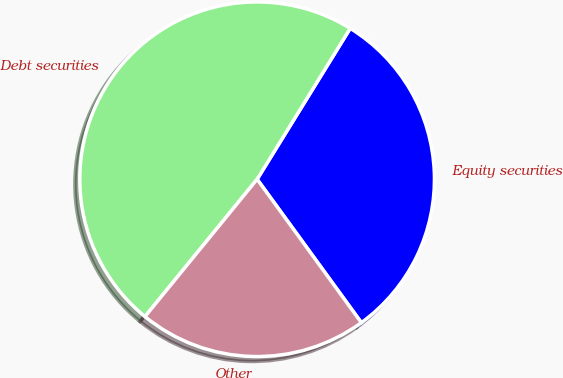Convert chart to OTSL. <chart><loc_0><loc_0><loc_500><loc_500><pie_chart><fcel>Equity securities<fcel>Debt securities<fcel>Other<nl><fcel>31.2%<fcel>47.9%<fcel>20.9%<nl></chart> 